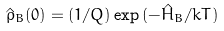<formula> <loc_0><loc_0><loc_500><loc_500>\hat { \rho } _ { B } ( 0 ) = ( 1 / Q ) \exp { ( - \hat { H } _ { B } / k T ) }</formula> 